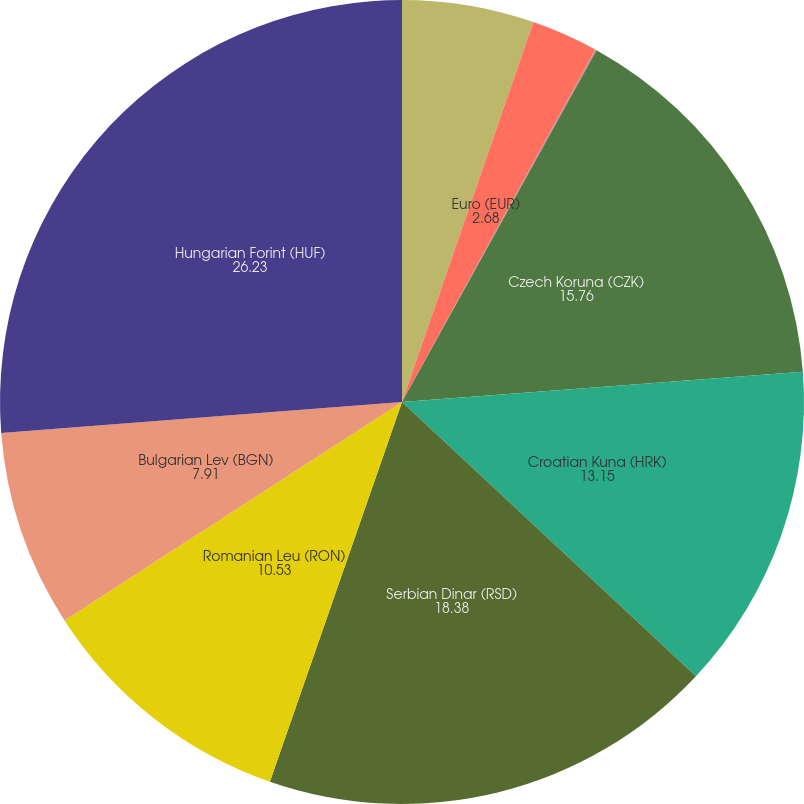Convert chart to OTSL. <chart><loc_0><loc_0><loc_500><loc_500><pie_chart><fcel>Canadian dollar (CAD)<fcel>Euro (EUR)<fcel>British pound (GBP)<fcel>Czech Koruna (CZK)<fcel>Croatian Kuna (HRK)<fcel>Serbian Dinar (RSD)<fcel>Romanian Leu (RON)<fcel>Bulgarian Lev (BGN)<fcel>Hungarian Forint (HUF)<nl><fcel>5.3%<fcel>2.68%<fcel>0.06%<fcel>15.76%<fcel>13.15%<fcel>18.38%<fcel>10.53%<fcel>7.91%<fcel>26.23%<nl></chart> 